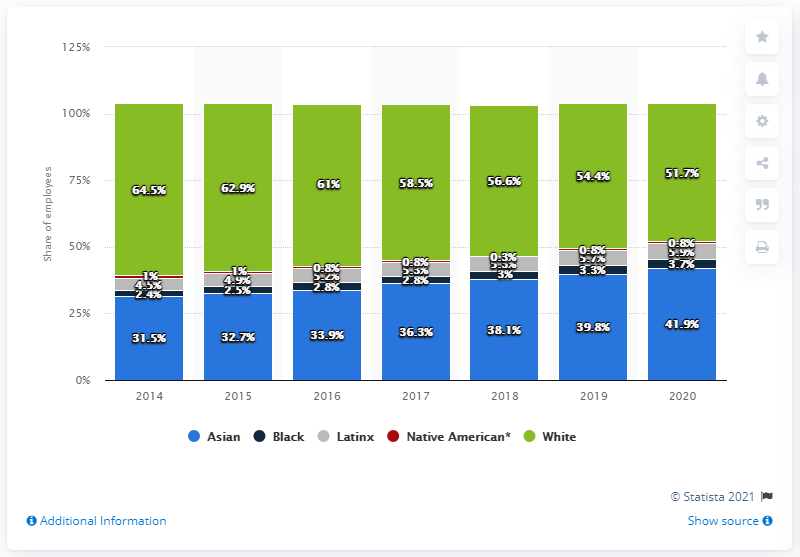List a handful of essential elements in this visual. Of Google employees, 5.9% were of Latinx ethnicity. 